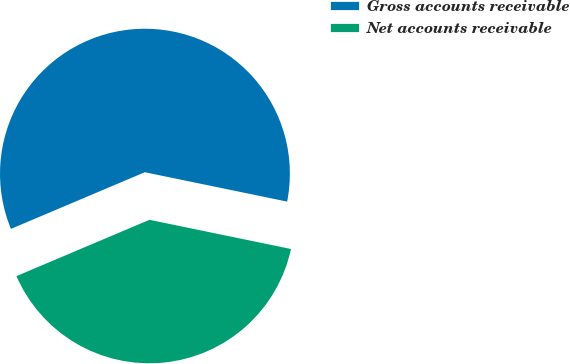<chart> <loc_0><loc_0><loc_500><loc_500><pie_chart><fcel>Gross accounts receivable<fcel>Net accounts receivable<nl><fcel>59.61%<fcel>40.39%<nl></chart> 